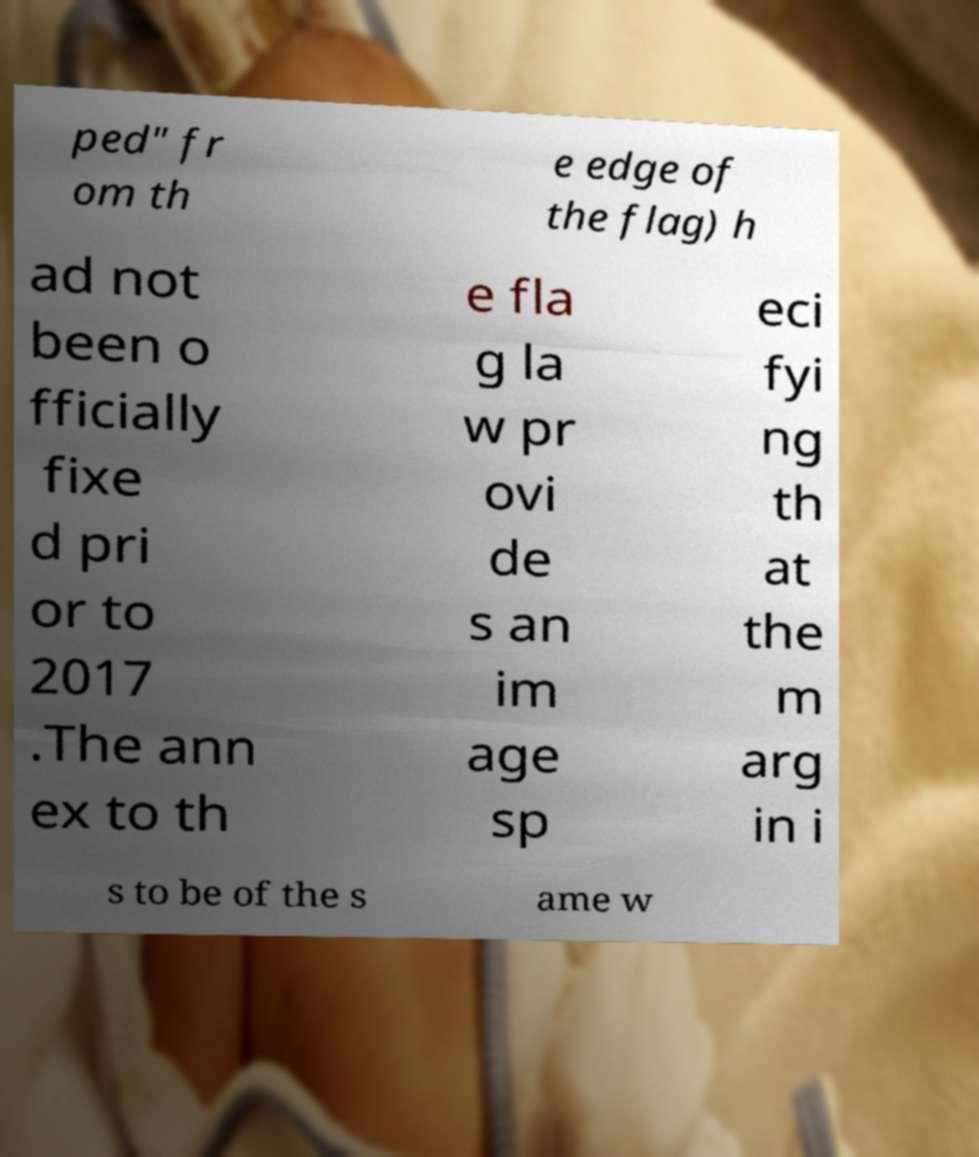Please identify and transcribe the text found in this image. ped" fr om th e edge of the flag) h ad not been o fficially fixe d pri or to 2017 .The ann ex to th e fla g la w pr ovi de s an im age sp eci fyi ng th at the m arg in i s to be of the s ame w 